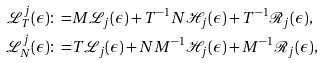<formula> <loc_0><loc_0><loc_500><loc_500>\mathcal { L } _ { T } ^ { j } ( \epsilon ) \colon = & M \mathcal { L } _ { j } ( \epsilon ) + T ^ { - 1 } N \mathcal { H } _ { j } ( \epsilon ) + T ^ { - 1 } \mathcal { R } _ { j } ( \epsilon ) , \\ \mathcal { L } _ { N } ^ { j } ( \epsilon ) \colon = & T \mathcal { L } _ { j } ( \epsilon ) + N M ^ { - 1 } \mathcal { H } _ { j } ( \epsilon ) + M ^ { - 1 } \mathcal { R } _ { j } ( \epsilon ) ,</formula> 